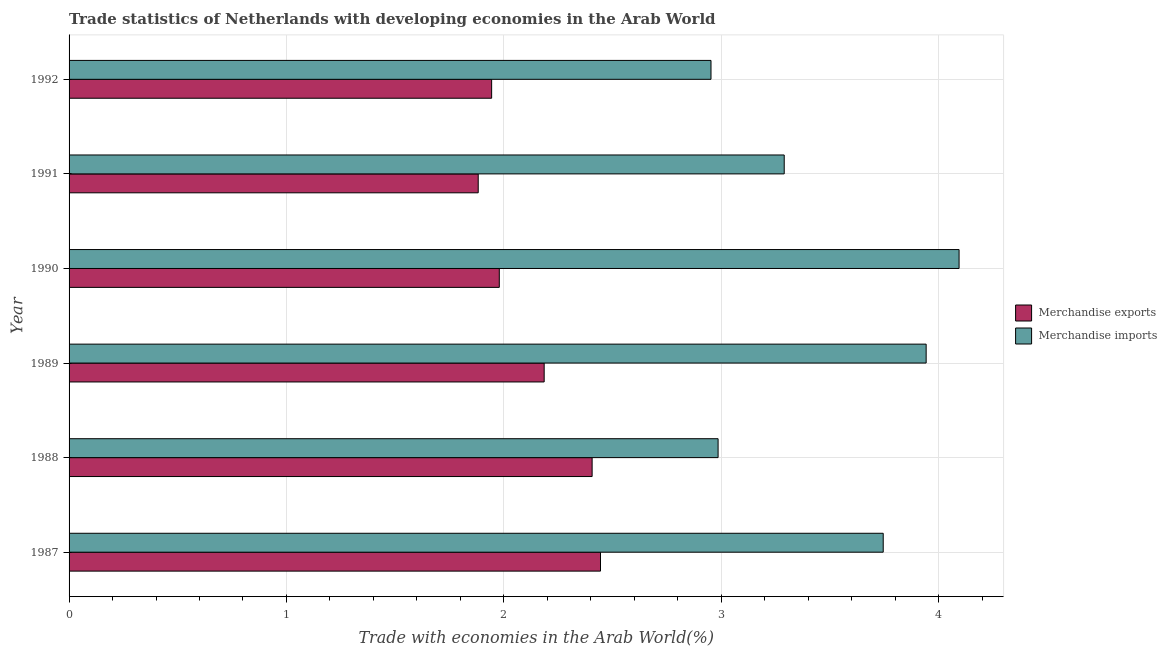Are the number of bars on each tick of the Y-axis equal?
Provide a succinct answer. Yes. How many bars are there on the 2nd tick from the top?
Keep it short and to the point. 2. How many bars are there on the 1st tick from the bottom?
Ensure brevity in your answer.  2. What is the merchandise imports in 1987?
Keep it short and to the point. 3.75. Across all years, what is the maximum merchandise exports?
Provide a succinct answer. 2.44. Across all years, what is the minimum merchandise imports?
Make the answer very short. 2.95. In which year was the merchandise imports maximum?
Make the answer very short. 1990. In which year was the merchandise exports minimum?
Provide a short and direct response. 1991. What is the total merchandise imports in the graph?
Provide a succinct answer. 21.01. What is the difference between the merchandise exports in 1988 and that in 1990?
Give a very brief answer. 0.43. What is the difference between the merchandise exports in 1989 and the merchandise imports in 1988?
Ensure brevity in your answer.  -0.8. What is the average merchandise exports per year?
Ensure brevity in your answer.  2.14. In the year 1987, what is the difference between the merchandise exports and merchandise imports?
Keep it short and to the point. -1.3. In how many years, is the merchandise exports greater than 3.6 %?
Provide a short and direct response. 0. What is the ratio of the merchandise exports in 1990 to that in 1992?
Offer a very short reply. 1.02. Is the merchandise exports in 1989 less than that in 1991?
Offer a terse response. No. Is the difference between the merchandise imports in 1988 and 1991 greater than the difference between the merchandise exports in 1988 and 1991?
Give a very brief answer. No. What is the difference between the highest and the second highest merchandise imports?
Ensure brevity in your answer.  0.15. What is the difference between the highest and the lowest merchandise imports?
Your answer should be compact. 1.14. Is the sum of the merchandise exports in 1988 and 1990 greater than the maximum merchandise imports across all years?
Provide a succinct answer. Yes. What does the 2nd bar from the bottom in 1987 represents?
Your answer should be compact. Merchandise imports. How many bars are there?
Offer a very short reply. 12. What is the difference between two consecutive major ticks on the X-axis?
Offer a terse response. 1. Are the values on the major ticks of X-axis written in scientific E-notation?
Make the answer very short. No. How many legend labels are there?
Offer a very short reply. 2. What is the title of the graph?
Your answer should be very brief. Trade statistics of Netherlands with developing economies in the Arab World. What is the label or title of the X-axis?
Offer a very short reply. Trade with economies in the Arab World(%). What is the Trade with economies in the Arab World(%) in Merchandise exports in 1987?
Make the answer very short. 2.44. What is the Trade with economies in the Arab World(%) of Merchandise imports in 1987?
Your answer should be compact. 3.75. What is the Trade with economies in the Arab World(%) of Merchandise exports in 1988?
Offer a terse response. 2.41. What is the Trade with economies in the Arab World(%) of Merchandise imports in 1988?
Your response must be concise. 2.99. What is the Trade with economies in the Arab World(%) in Merchandise exports in 1989?
Your answer should be compact. 2.19. What is the Trade with economies in the Arab World(%) of Merchandise imports in 1989?
Offer a terse response. 3.94. What is the Trade with economies in the Arab World(%) in Merchandise exports in 1990?
Your answer should be very brief. 1.98. What is the Trade with economies in the Arab World(%) of Merchandise imports in 1990?
Your response must be concise. 4.09. What is the Trade with economies in the Arab World(%) in Merchandise exports in 1991?
Your answer should be very brief. 1.88. What is the Trade with economies in the Arab World(%) of Merchandise imports in 1991?
Offer a very short reply. 3.29. What is the Trade with economies in the Arab World(%) of Merchandise exports in 1992?
Ensure brevity in your answer.  1.94. What is the Trade with economies in the Arab World(%) of Merchandise imports in 1992?
Give a very brief answer. 2.95. Across all years, what is the maximum Trade with economies in the Arab World(%) in Merchandise exports?
Make the answer very short. 2.44. Across all years, what is the maximum Trade with economies in the Arab World(%) in Merchandise imports?
Provide a succinct answer. 4.09. Across all years, what is the minimum Trade with economies in the Arab World(%) of Merchandise exports?
Your response must be concise. 1.88. Across all years, what is the minimum Trade with economies in the Arab World(%) of Merchandise imports?
Offer a terse response. 2.95. What is the total Trade with economies in the Arab World(%) in Merchandise exports in the graph?
Keep it short and to the point. 12.84. What is the total Trade with economies in the Arab World(%) in Merchandise imports in the graph?
Keep it short and to the point. 21.01. What is the difference between the Trade with economies in the Arab World(%) in Merchandise exports in 1987 and that in 1988?
Make the answer very short. 0.04. What is the difference between the Trade with economies in the Arab World(%) of Merchandise imports in 1987 and that in 1988?
Provide a succinct answer. 0.76. What is the difference between the Trade with economies in the Arab World(%) in Merchandise exports in 1987 and that in 1989?
Provide a succinct answer. 0.26. What is the difference between the Trade with economies in the Arab World(%) in Merchandise imports in 1987 and that in 1989?
Offer a very short reply. -0.2. What is the difference between the Trade with economies in the Arab World(%) of Merchandise exports in 1987 and that in 1990?
Make the answer very short. 0.47. What is the difference between the Trade with economies in the Arab World(%) of Merchandise imports in 1987 and that in 1990?
Give a very brief answer. -0.35. What is the difference between the Trade with economies in the Arab World(%) in Merchandise exports in 1987 and that in 1991?
Ensure brevity in your answer.  0.56. What is the difference between the Trade with economies in the Arab World(%) of Merchandise imports in 1987 and that in 1991?
Make the answer very short. 0.46. What is the difference between the Trade with economies in the Arab World(%) in Merchandise exports in 1987 and that in 1992?
Your response must be concise. 0.5. What is the difference between the Trade with economies in the Arab World(%) of Merchandise imports in 1987 and that in 1992?
Keep it short and to the point. 0.79. What is the difference between the Trade with economies in the Arab World(%) of Merchandise exports in 1988 and that in 1989?
Provide a short and direct response. 0.22. What is the difference between the Trade with economies in the Arab World(%) in Merchandise imports in 1988 and that in 1989?
Ensure brevity in your answer.  -0.96. What is the difference between the Trade with economies in the Arab World(%) of Merchandise exports in 1988 and that in 1990?
Keep it short and to the point. 0.43. What is the difference between the Trade with economies in the Arab World(%) of Merchandise imports in 1988 and that in 1990?
Provide a short and direct response. -1.11. What is the difference between the Trade with economies in the Arab World(%) in Merchandise exports in 1988 and that in 1991?
Your response must be concise. 0.52. What is the difference between the Trade with economies in the Arab World(%) in Merchandise imports in 1988 and that in 1991?
Provide a succinct answer. -0.3. What is the difference between the Trade with economies in the Arab World(%) in Merchandise exports in 1988 and that in 1992?
Your response must be concise. 0.46. What is the difference between the Trade with economies in the Arab World(%) in Merchandise imports in 1988 and that in 1992?
Give a very brief answer. 0.03. What is the difference between the Trade with economies in the Arab World(%) in Merchandise exports in 1989 and that in 1990?
Make the answer very short. 0.21. What is the difference between the Trade with economies in the Arab World(%) in Merchandise imports in 1989 and that in 1990?
Your answer should be compact. -0.15. What is the difference between the Trade with economies in the Arab World(%) of Merchandise exports in 1989 and that in 1991?
Give a very brief answer. 0.3. What is the difference between the Trade with economies in the Arab World(%) in Merchandise imports in 1989 and that in 1991?
Offer a terse response. 0.65. What is the difference between the Trade with economies in the Arab World(%) of Merchandise exports in 1989 and that in 1992?
Your answer should be compact. 0.24. What is the difference between the Trade with economies in the Arab World(%) of Merchandise imports in 1989 and that in 1992?
Provide a succinct answer. 0.99. What is the difference between the Trade with economies in the Arab World(%) in Merchandise exports in 1990 and that in 1991?
Your answer should be compact. 0.1. What is the difference between the Trade with economies in the Arab World(%) in Merchandise imports in 1990 and that in 1991?
Offer a terse response. 0.8. What is the difference between the Trade with economies in the Arab World(%) of Merchandise exports in 1990 and that in 1992?
Make the answer very short. 0.04. What is the difference between the Trade with economies in the Arab World(%) of Merchandise imports in 1990 and that in 1992?
Provide a succinct answer. 1.14. What is the difference between the Trade with economies in the Arab World(%) in Merchandise exports in 1991 and that in 1992?
Your answer should be very brief. -0.06. What is the difference between the Trade with economies in the Arab World(%) in Merchandise imports in 1991 and that in 1992?
Offer a very short reply. 0.34. What is the difference between the Trade with economies in the Arab World(%) in Merchandise exports in 1987 and the Trade with economies in the Arab World(%) in Merchandise imports in 1988?
Offer a terse response. -0.54. What is the difference between the Trade with economies in the Arab World(%) of Merchandise exports in 1987 and the Trade with economies in the Arab World(%) of Merchandise imports in 1989?
Keep it short and to the point. -1.5. What is the difference between the Trade with economies in the Arab World(%) of Merchandise exports in 1987 and the Trade with economies in the Arab World(%) of Merchandise imports in 1990?
Provide a short and direct response. -1.65. What is the difference between the Trade with economies in the Arab World(%) in Merchandise exports in 1987 and the Trade with economies in the Arab World(%) in Merchandise imports in 1991?
Your response must be concise. -0.85. What is the difference between the Trade with economies in the Arab World(%) of Merchandise exports in 1987 and the Trade with economies in the Arab World(%) of Merchandise imports in 1992?
Your answer should be compact. -0.51. What is the difference between the Trade with economies in the Arab World(%) in Merchandise exports in 1988 and the Trade with economies in the Arab World(%) in Merchandise imports in 1989?
Your response must be concise. -1.54. What is the difference between the Trade with economies in the Arab World(%) in Merchandise exports in 1988 and the Trade with economies in the Arab World(%) in Merchandise imports in 1990?
Provide a short and direct response. -1.69. What is the difference between the Trade with economies in the Arab World(%) in Merchandise exports in 1988 and the Trade with economies in the Arab World(%) in Merchandise imports in 1991?
Make the answer very short. -0.88. What is the difference between the Trade with economies in the Arab World(%) in Merchandise exports in 1988 and the Trade with economies in the Arab World(%) in Merchandise imports in 1992?
Offer a terse response. -0.55. What is the difference between the Trade with economies in the Arab World(%) of Merchandise exports in 1989 and the Trade with economies in the Arab World(%) of Merchandise imports in 1990?
Ensure brevity in your answer.  -1.91. What is the difference between the Trade with economies in the Arab World(%) in Merchandise exports in 1989 and the Trade with economies in the Arab World(%) in Merchandise imports in 1991?
Give a very brief answer. -1.1. What is the difference between the Trade with economies in the Arab World(%) in Merchandise exports in 1989 and the Trade with economies in the Arab World(%) in Merchandise imports in 1992?
Your answer should be very brief. -0.77. What is the difference between the Trade with economies in the Arab World(%) in Merchandise exports in 1990 and the Trade with economies in the Arab World(%) in Merchandise imports in 1991?
Your response must be concise. -1.31. What is the difference between the Trade with economies in the Arab World(%) of Merchandise exports in 1990 and the Trade with economies in the Arab World(%) of Merchandise imports in 1992?
Your answer should be compact. -0.97. What is the difference between the Trade with economies in the Arab World(%) of Merchandise exports in 1991 and the Trade with economies in the Arab World(%) of Merchandise imports in 1992?
Your response must be concise. -1.07. What is the average Trade with economies in the Arab World(%) of Merchandise exports per year?
Give a very brief answer. 2.14. What is the average Trade with economies in the Arab World(%) of Merchandise imports per year?
Offer a very short reply. 3.5. In the year 1987, what is the difference between the Trade with economies in the Arab World(%) in Merchandise exports and Trade with economies in the Arab World(%) in Merchandise imports?
Your answer should be compact. -1.3. In the year 1988, what is the difference between the Trade with economies in the Arab World(%) of Merchandise exports and Trade with economies in the Arab World(%) of Merchandise imports?
Provide a succinct answer. -0.58. In the year 1989, what is the difference between the Trade with economies in the Arab World(%) of Merchandise exports and Trade with economies in the Arab World(%) of Merchandise imports?
Offer a terse response. -1.76. In the year 1990, what is the difference between the Trade with economies in the Arab World(%) in Merchandise exports and Trade with economies in the Arab World(%) in Merchandise imports?
Keep it short and to the point. -2.12. In the year 1991, what is the difference between the Trade with economies in the Arab World(%) of Merchandise exports and Trade with economies in the Arab World(%) of Merchandise imports?
Give a very brief answer. -1.41. In the year 1992, what is the difference between the Trade with economies in the Arab World(%) in Merchandise exports and Trade with economies in the Arab World(%) in Merchandise imports?
Provide a succinct answer. -1.01. What is the ratio of the Trade with economies in the Arab World(%) of Merchandise exports in 1987 to that in 1988?
Your response must be concise. 1.02. What is the ratio of the Trade with economies in the Arab World(%) in Merchandise imports in 1987 to that in 1988?
Your response must be concise. 1.25. What is the ratio of the Trade with economies in the Arab World(%) in Merchandise exports in 1987 to that in 1989?
Provide a succinct answer. 1.12. What is the ratio of the Trade with economies in the Arab World(%) in Merchandise imports in 1987 to that in 1989?
Your answer should be compact. 0.95. What is the ratio of the Trade with economies in the Arab World(%) in Merchandise exports in 1987 to that in 1990?
Your answer should be compact. 1.24. What is the ratio of the Trade with economies in the Arab World(%) of Merchandise imports in 1987 to that in 1990?
Make the answer very short. 0.91. What is the ratio of the Trade with economies in the Arab World(%) of Merchandise exports in 1987 to that in 1991?
Offer a terse response. 1.3. What is the ratio of the Trade with economies in the Arab World(%) in Merchandise imports in 1987 to that in 1991?
Provide a short and direct response. 1.14. What is the ratio of the Trade with economies in the Arab World(%) in Merchandise exports in 1987 to that in 1992?
Your answer should be very brief. 1.26. What is the ratio of the Trade with economies in the Arab World(%) in Merchandise imports in 1987 to that in 1992?
Make the answer very short. 1.27. What is the ratio of the Trade with economies in the Arab World(%) in Merchandise exports in 1988 to that in 1989?
Your answer should be compact. 1.1. What is the ratio of the Trade with economies in the Arab World(%) in Merchandise imports in 1988 to that in 1989?
Give a very brief answer. 0.76. What is the ratio of the Trade with economies in the Arab World(%) of Merchandise exports in 1988 to that in 1990?
Offer a terse response. 1.22. What is the ratio of the Trade with economies in the Arab World(%) in Merchandise imports in 1988 to that in 1990?
Your answer should be compact. 0.73. What is the ratio of the Trade with economies in the Arab World(%) of Merchandise exports in 1988 to that in 1991?
Keep it short and to the point. 1.28. What is the ratio of the Trade with economies in the Arab World(%) of Merchandise imports in 1988 to that in 1991?
Provide a short and direct response. 0.91. What is the ratio of the Trade with economies in the Arab World(%) in Merchandise exports in 1988 to that in 1992?
Your response must be concise. 1.24. What is the ratio of the Trade with economies in the Arab World(%) of Merchandise imports in 1988 to that in 1992?
Offer a very short reply. 1.01. What is the ratio of the Trade with economies in the Arab World(%) of Merchandise exports in 1989 to that in 1990?
Your answer should be compact. 1.1. What is the ratio of the Trade with economies in the Arab World(%) of Merchandise imports in 1989 to that in 1990?
Provide a short and direct response. 0.96. What is the ratio of the Trade with economies in the Arab World(%) of Merchandise exports in 1989 to that in 1991?
Offer a terse response. 1.16. What is the ratio of the Trade with economies in the Arab World(%) in Merchandise imports in 1989 to that in 1991?
Your answer should be compact. 1.2. What is the ratio of the Trade with economies in the Arab World(%) of Merchandise exports in 1989 to that in 1992?
Give a very brief answer. 1.12. What is the ratio of the Trade with economies in the Arab World(%) of Merchandise imports in 1989 to that in 1992?
Give a very brief answer. 1.34. What is the ratio of the Trade with economies in the Arab World(%) of Merchandise exports in 1990 to that in 1991?
Your response must be concise. 1.05. What is the ratio of the Trade with economies in the Arab World(%) of Merchandise imports in 1990 to that in 1991?
Make the answer very short. 1.24. What is the ratio of the Trade with economies in the Arab World(%) in Merchandise exports in 1990 to that in 1992?
Your answer should be compact. 1.02. What is the ratio of the Trade with economies in the Arab World(%) in Merchandise imports in 1990 to that in 1992?
Provide a short and direct response. 1.39. What is the ratio of the Trade with economies in the Arab World(%) of Merchandise exports in 1991 to that in 1992?
Make the answer very short. 0.97. What is the ratio of the Trade with economies in the Arab World(%) in Merchandise imports in 1991 to that in 1992?
Provide a succinct answer. 1.11. What is the difference between the highest and the second highest Trade with economies in the Arab World(%) in Merchandise exports?
Your answer should be compact. 0.04. What is the difference between the highest and the second highest Trade with economies in the Arab World(%) in Merchandise imports?
Offer a very short reply. 0.15. What is the difference between the highest and the lowest Trade with economies in the Arab World(%) in Merchandise exports?
Your answer should be very brief. 0.56. What is the difference between the highest and the lowest Trade with economies in the Arab World(%) of Merchandise imports?
Ensure brevity in your answer.  1.14. 